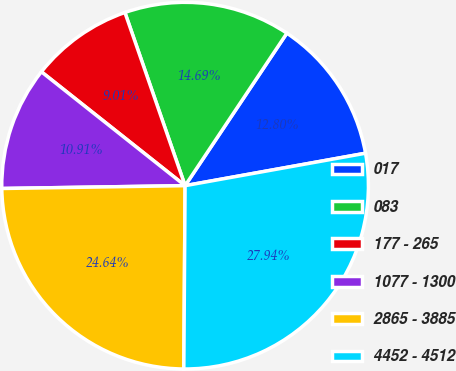Convert chart. <chart><loc_0><loc_0><loc_500><loc_500><pie_chart><fcel>017<fcel>083<fcel>177 - 265<fcel>1077 - 1300<fcel>2865 - 3885<fcel>4452 - 4512<nl><fcel>12.8%<fcel>14.69%<fcel>9.01%<fcel>10.91%<fcel>24.64%<fcel>27.94%<nl></chart> 